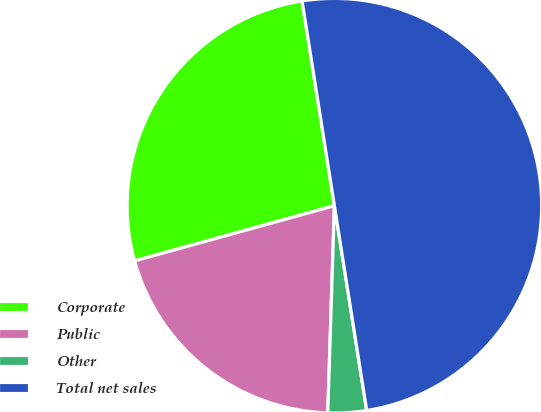<chart> <loc_0><loc_0><loc_500><loc_500><pie_chart><fcel>Corporate<fcel>Public<fcel>Other<fcel>Total net sales<nl><fcel>26.8%<fcel>20.2%<fcel>3.0%<fcel>50.0%<nl></chart> 